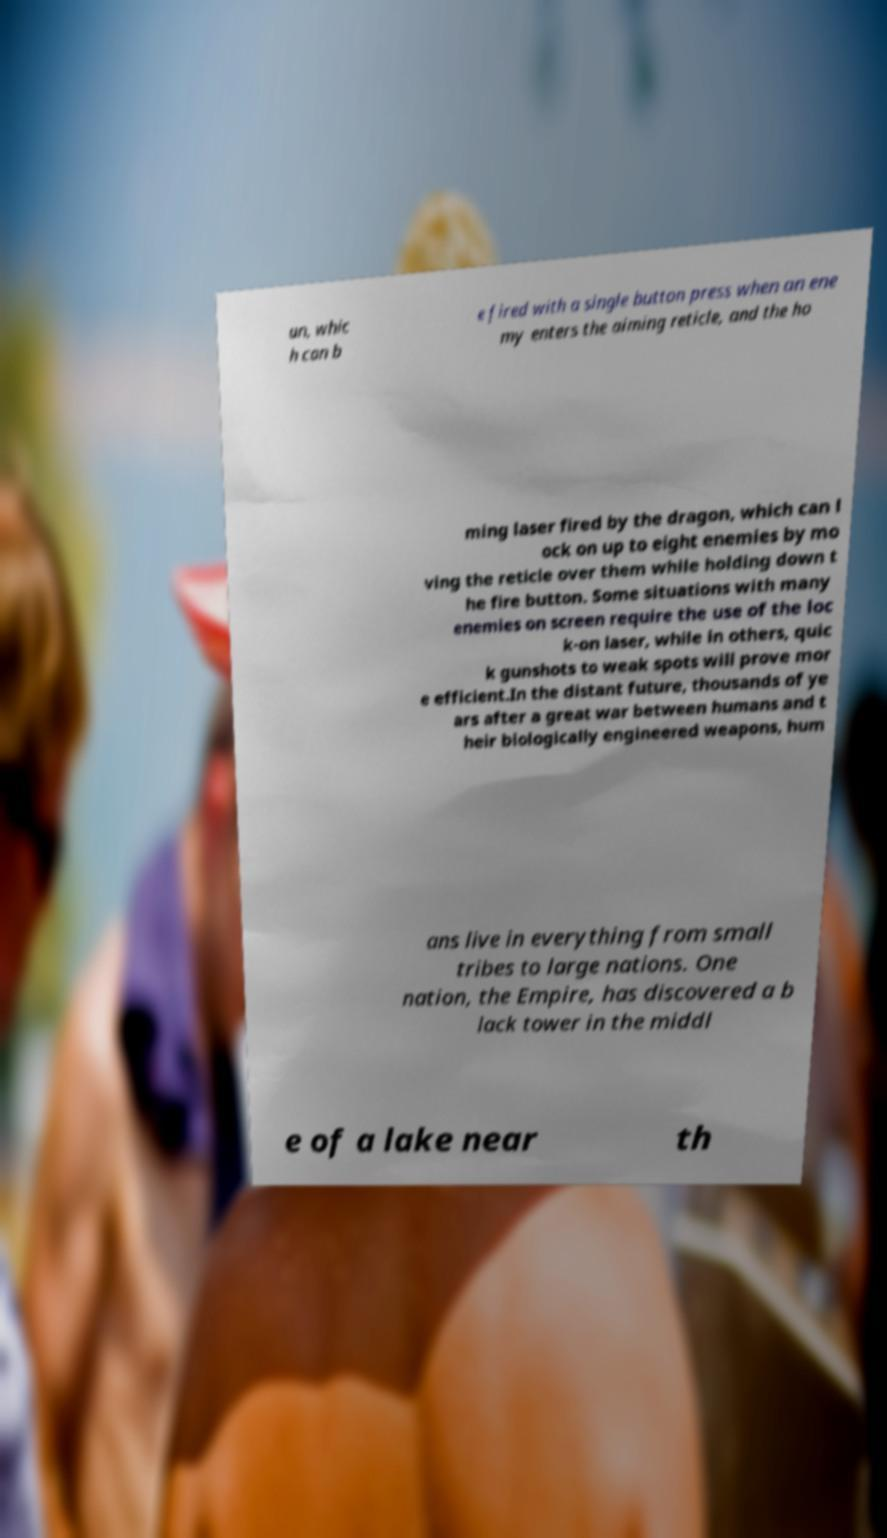Can you accurately transcribe the text from the provided image for me? un, whic h can b e fired with a single button press when an ene my enters the aiming reticle, and the ho ming laser fired by the dragon, which can l ock on up to eight enemies by mo ving the reticle over them while holding down t he fire button. Some situations with many enemies on screen require the use of the loc k-on laser, while in others, quic k gunshots to weak spots will prove mor e efficient.In the distant future, thousands of ye ars after a great war between humans and t heir biologically engineered weapons, hum ans live in everything from small tribes to large nations. One nation, the Empire, has discovered a b lack tower in the middl e of a lake near th 